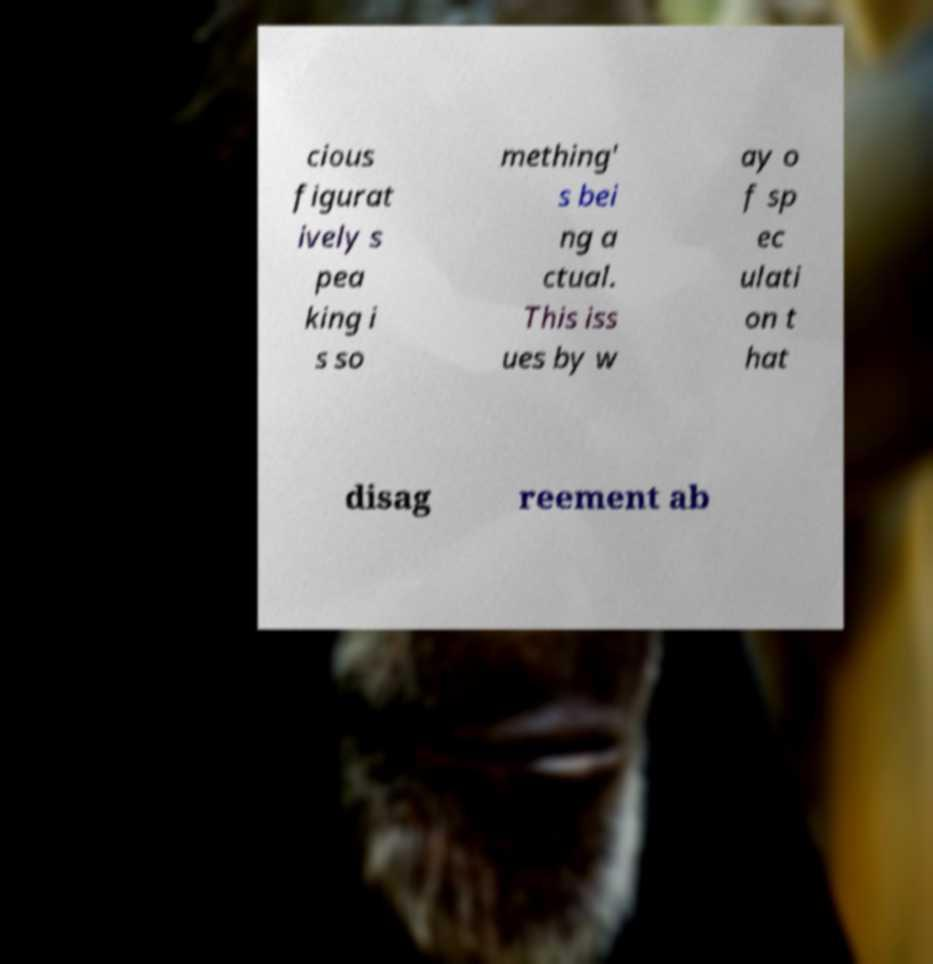I need the written content from this picture converted into text. Can you do that? cious figurat ively s pea king i s so mething' s bei ng a ctual. This iss ues by w ay o f sp ec ulati on t hat disag reement ab 